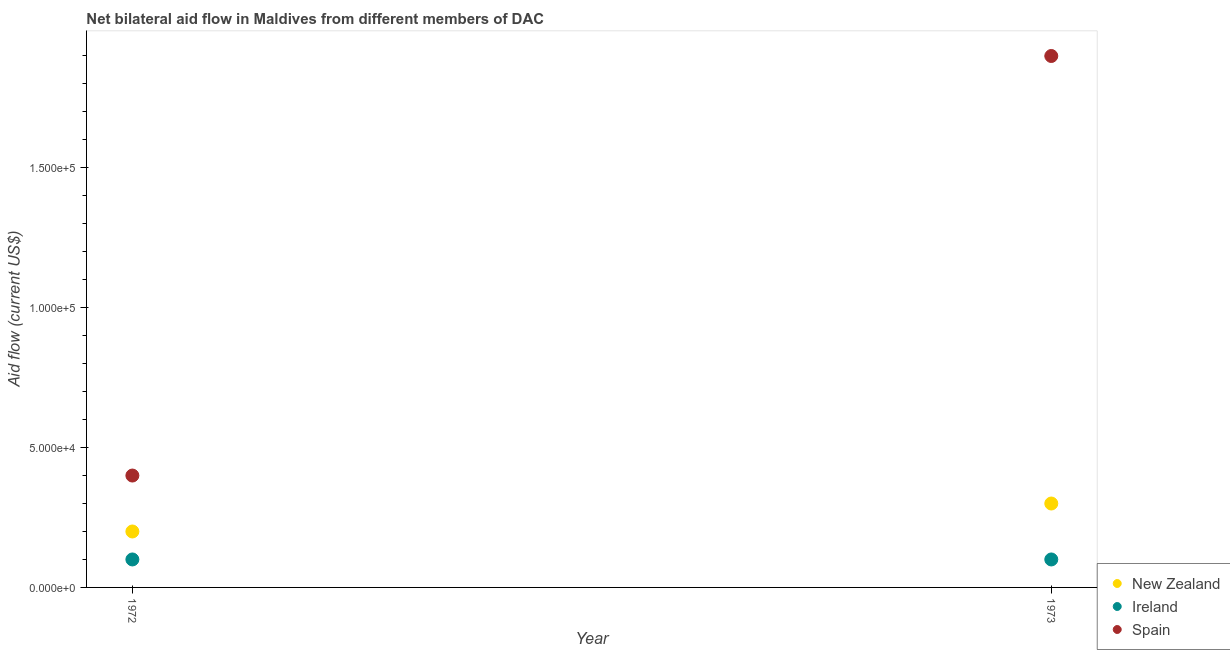What is the amount of aid provided by ireland in 1972?
Ensure brevity in your answer.  10000. Across all years, what is the maximum amount of aid provided by ireland?
Your response must be concise. 10000. Across all years, what is the minimum amount of aid provided by spain?
Keep it short and to the point. 4.00e+04. In which year was the amount of aid provided by ireland minimum?
Keep it short and to the point. 1972. What is the total amount of aid provided by new zealand in the graph?
Provide a short and direct response. 5.00e+04. What is the difference between the amount of aid provided by spain in 1972 and that in 1973?
Keep it short and to the point. -1.50e+05. What is the difference between the amount of aid provided by ireland in 1972 and the amount of aid provided by spain in 1973?
Your answer should be compact. -1.80e+05. What is the average amount of aid provided by spain per year?
Provide a succinct answer. 1.15e+05. In the year 1973, what is the difference between the amount of aid provided by ireland and amount of aid provided by spain?
Provide a short and direct response. -1.80e+05. Is the amount of aid provided by ireland in 1972 less than that in 1973?
Make the answer very short. No. Is it the case that in every year, the sum of the amount of aid provided by new zealand and amount of aid provided by ireland is greater than the amount of aid provided by spain?
Your answer should be compact. No. Is the amount of aid provided by new zealand strictly less than the amount of aid provided by ireland over the years?
Provide a succinct answer. No. Are the values on the major ticks of Y-axis written in scientific E-notation?
Your answer should be very brief. Yes. Does the graph contain any zero values?
Your answer should be very brief. No. Does the graph contain grids?
Offer a terse response. No. Where does the legend appear in the graph?
Make the answer very short. Bottom right. How many legend labels are there?
Provide a short and direct response. 3. What is the title of the graph?
Keep it short and to the point. Net bilateral aid flow in Maldives from different members of DAC. What is the label or title of the Y-axis?
Your answer should be very brief. Aid flow (current US$). What is the Aid flow (current US$) in Spain in 1972?
Your response must be concise. 4.00e+04. Across all years, what is the maximum Aid flow (current US$) in Ireland?
Your answer should be compact. 10000. Across all years, what is the maximum Aid flow (current US$) in Spain?
Offer a very short reply. 1.90e+05. Across all years, what is the minimum Aid flow (current US$) of Ireland?
Offer a very short reply. 10000. What is the total Aid flow (current US$) in Spain in the graph?
Provide a short and direct response. 2.30e+05. What is the difference between the Aid flow (current US$) in New Zealand in 1972 and that in 1973?
Provide a succinct answer. -10000. What is the difference between the Aid flow (current US$) of Ireland in 1972 and that in 1973?
Offer a very short reply. 0. What is the difference between the Aid flow (current US$) in Spain in 1972 and that in 1973?
Offer a terse response. -1.50e+05. What is the difference between the Aid flow (current US$) of New Zealand in 1972 and the Aid flow (current US$) of Ireland in 1973?
Ensure brevity in your answer.  10000. What is the difference between the Aid flow (current US$) of New Zealand in 1972 and the Aid flow (current US$) of Spain in 1973?
Ensure brevity in your answer.  -1.70e+05. What is the difference between the Aid flow (current US$) in Ireland in 1972 and the Aid flow (current US$) in Spain in 1973?
Ensure brevity in your answer.  -1.80e+05. What is the average Aid flow (current US$) in New Zealand per year?
Your answer should be very brief. 2.50e+04. What is the average Aid flow (current US$) of Ireland per year?
Your answer should be compact. 10000. What is the average Aid flow (current US$) in Spain per year?
Provide a short and direct response. 1.15e+05. In the year 1973, what is the difference between the Aid flow (current US$) of New Zealand and Aid flow (current US$) of Ireland?
Your answer should be very brief. 2.00e+04. In the year 1973, what is the difference between the Aid flow (current US$) of New Zealand and Aid flow (current US$) of Spain?
Offer a very short reply. -1.60e+05. In the year 1973, what is the difference between the Aid flow (current US$) of Ireland and Aid flow (current US$) of Spain?
Keep it short and to the point. -1.80e+05. What is the ratio of the Aid flow (current US$) in Spain in 1972 to that in 1973?
Give a very brief answer. 0.21. What is the difference between the highest and the second highest Aid flow (current US$) of Ireland?
Give a very brief answer. 0. What is the difference between the highest and the second highest Aid flow (current US$) in Spain?
Your answer should be compact. 1.50e+05. What is the difference between the highest and the lowest Aid flow (current US$) of Ireland?
Keep it short and to the point. 0. What is the difference between the highest and the lowest Aid flow (current US$) in Spain?
Your answer should be compact. 1.50e+05. 